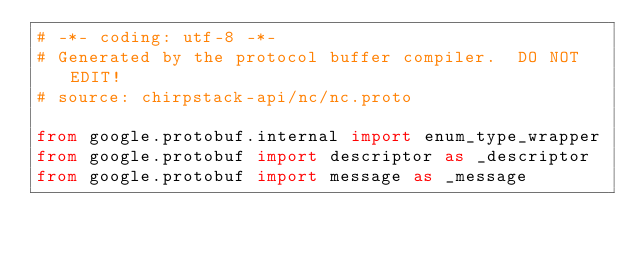Convert code to text. <code><loc_0><loc_0><loc_500><loc_500><_Python_># -*- coding: utf-8 -*-
# Generated by the protocol buffer compiler.  DO NOT EDIT!
# source: chirpstack-api/nc/nc.proto

from google.protobuf.internal import enum_type_wrapper
from google.protobuf import descriptor as _descriptor
from google.protobuf import message as _message</code> 